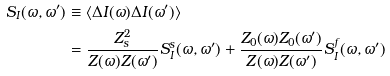<formula> <loc_0><loc_0><loc_500><loc_500>S _ { I } ( \omega , \omega ^ { \prime } ) & \equiv \langle \Delta I ( \omega ) \Delta I ( \omega ^ { \prime } ) \rangle \\ & = \frac { Z _ { s } ^ { 2 } } { Z ( \omega ) Z ( \omega ^ { \prime } ) } S _ { I } ^ { s } ( \omega , \omega ^ { \prime } ) + \frac { Z _ { 0 } ( \omega ) Z _ { 0 } ( \omega ^ { \prime } ) } { Z ( \omega ) Z ( \omega ^ { \prime } ) } S _ { I } ^ { f } ( \omega , \omega ^ { \prime } )</formula> 